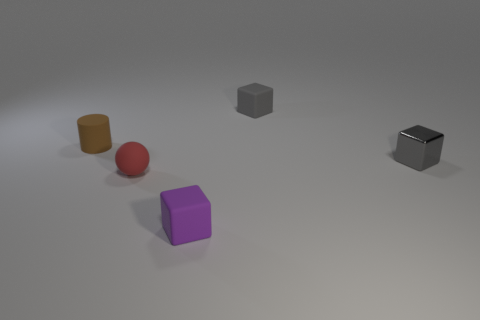Add 1 gray blocks. How many objects exist? 6 Subtract all matte cubes. How many cubes are left? 1 Subtract all cubes. How many objects are left? 2 Subtract 1 cylinders. How many cylinders are left? 0 Subtract all purple cubes. How many cubes are left? 2 Subtract 1 red spheres. How many objects are left? 4 Subtract all yellow cylinders. Subtract all red cubes. How many cylinders are left? 1 Subtract all yellow cylinders. How many gray cubes are left? 2 Subtract all cylinders. Subtract all tiny gray cubes. How many objects are left? 2 Add 2 tiny purple objects. How many tiny purple objects are left? 3 